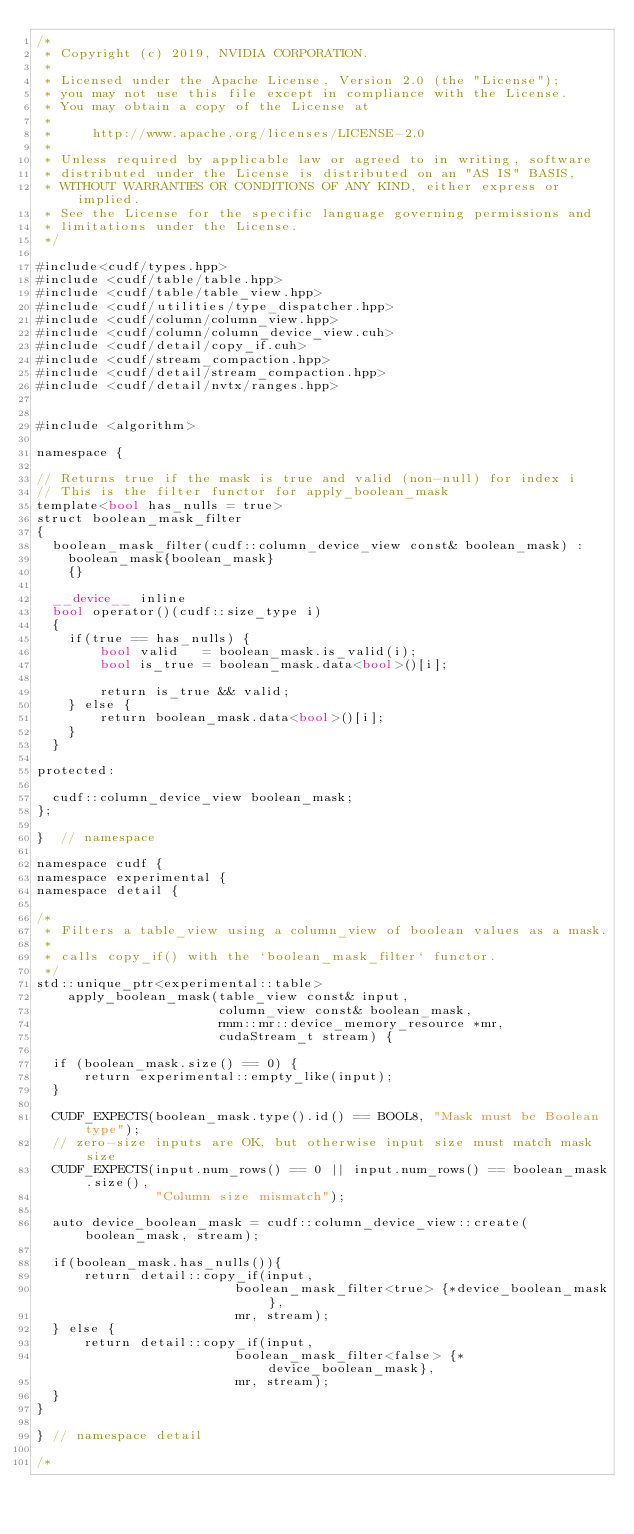Convert code to text. <code><loc_0><loc_0><loc_500><loc_500><_Cuda_>/*
 * Copyright (c) 2019, NVIDIA CORPORATION.
 *
 * Licensed under the Apache License, Version 2.0 (the "License");
 * you may not use this file except in compliance with the License.
 * You may obtain a copy of the License at
 *
 *     http://www.apache.org/licenses/LICENSE-2.0
 *
 * Unless required by applicable law or agreed to in writing, software
 * distributed under the License is distributed on an "AS IS" BASIS,
 * WITHOUT WARRANTIES OR CONDITIONS OF ANY KIND, either express or implied.
 * See the License for the specific language governing permissions and
 * limitations under the License.
 */

#include<cudf/types.hpp>
#include <cudf/table/table.hpp>
#include <cudf/table/table_view.hpp>
#include <cudf/utilities/type_dispatcher.hpp>
#include <cudf/column/column_view.hpp>
#include <cudf/column/column_device_view.cuh>
#include <cudf/detail/copy_if.cuh>
#include <cudf/stream_compaction.hpp>
#include <cudf/detail/stream_compaction.hpp>
#include <cudf/detail/nvtx/ranges.hpp>


#include <algorithm>

namespace {

// Returns true if the mask is true and valid (non-null) for index i
// This is the filter functor for apply_boolean_mask
template<bool has_nulls = true>
struct boolean_mask_filter
{
  boolean_mask_filter(cudf::column_device_view const& boolean_mask) :
    boolean_mask{boolean_mask}
    {}

  __device__ inline
  bool operator()(cudf::size_type i)
  {
    if(true == has_nulls) {
        bool valid   = boolean_mask.is_valid(i);
        bool is_true = boolean_mask.data<bool>()[i];
    
        return is_true && valid;
    } else {
        return boolean_mask.data<bool>()[i];
    }
  }

protected:

  cudf::column_device_view boolean_mask;
};

}  // namespace

namespace cudf {
namespace experimental {
namespace detail {

/*
 * Filters a table_view using a column_view of boolean values as a mask.
 *
 * calls copy_if() with the `boolean_mask_filter` functor.
 */
std::unique_ptr<experimental::table> 
    apply_boolean_mask(table_view const& input,
                       column_view const& boolean_mask,
                       rmm::mr::device_memory_resource *mr,
                       cudaStream_t stream) {

  if (boolean_mask.size() == 0) {
      return experimental::empty_like(input);
  }

  CUDF_EXPECTS(boolean_mask.type().id() == BOOL8, "Mask must be Boolean type");
  // zero-size inputs are OK, but otherwise input size must match mask size
  CUDF_EXPECTS(input.num_rows() == 0 || input.num_rows() == boolean_mask.size(),
               "Column size mismatch");

  auto device_boolean_mask = cudf::column_device_view::create(boolean_mask, stream);
  
  if(boolean_mask.has_nulls()){
      return detail::copy_if(input,
                         boolean_mask_filter<true> {*device_boolean_mask},
                         mr, stream);
  } else {
      return detail::copy_if(input,
                         boolean_mask_filter<false> {*device_boolean_mask},
                         mr, stream);
  }
}

} // namespace detail

/*</code> 